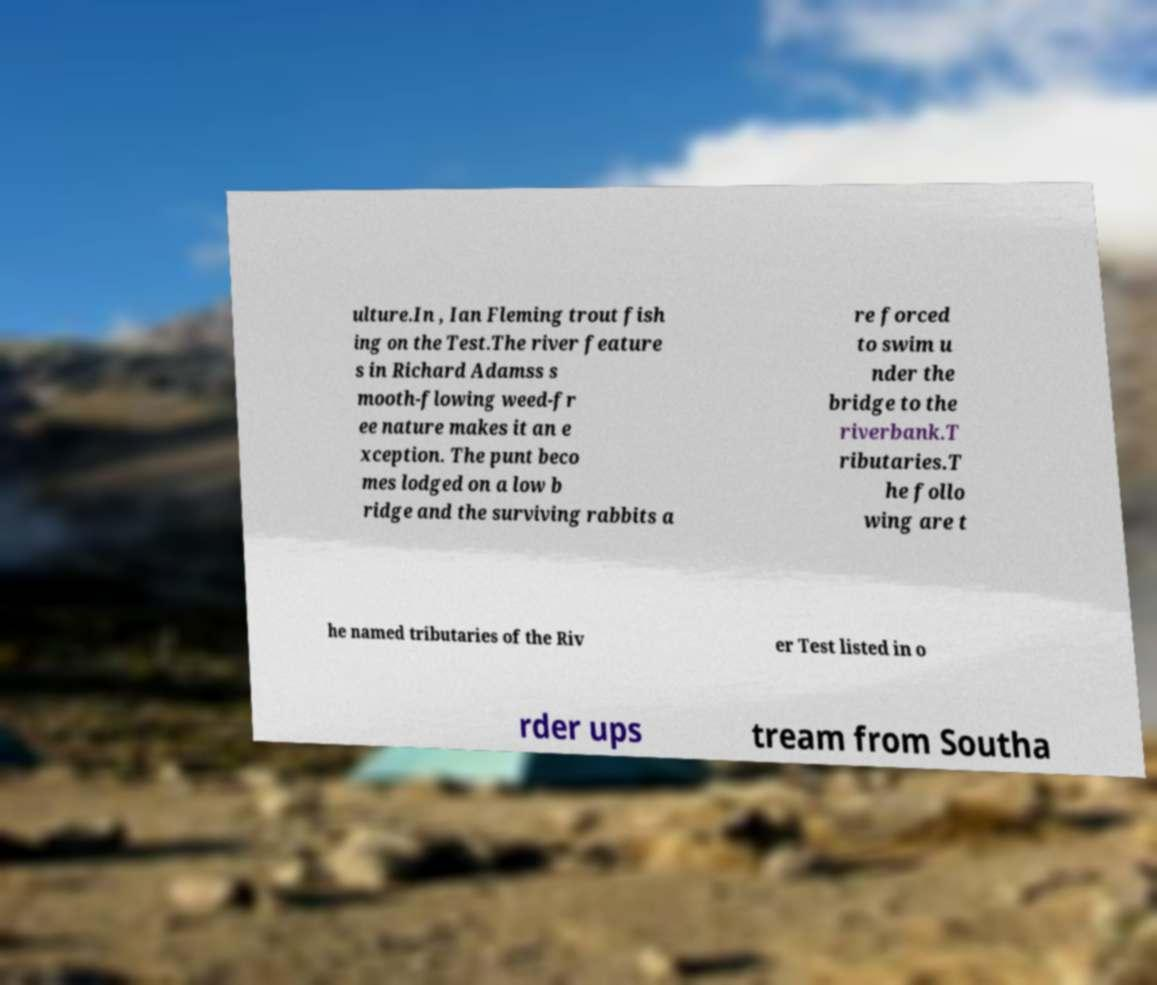Could you assist in decoding the text presented in this image and type it out clearly? ulture.In , Ian Fleming trout fish ing on the Test.The river feature s in Richard Adamss s mooth-flowing weed-fr ee nature makes it an e xception. The punt beco mes lodged on a low b ridge and the surviving rabbits a re forced to swim u nder the bridge to the riverbank.T ributaries.T he follo wing are t he named tributaries of the Riv er Test listed in o rder ups tream from Southa 